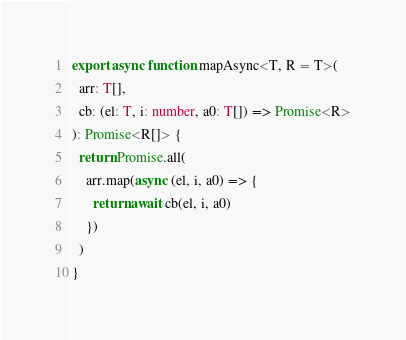<code> <loc_0><loc_0><loc_500><loc_500><_TypeScript_>export async function mapAsync<T, R = T>(
  arr: T[],
  cb: (el: T, i: number, a0: T[]) => Promise<R>
): Promise<R[]> {
  return Promise.all(
    arr.map(async (el, i, a0) => {
      return await cb(el, i, a0)
    })
  )
}
</code> 